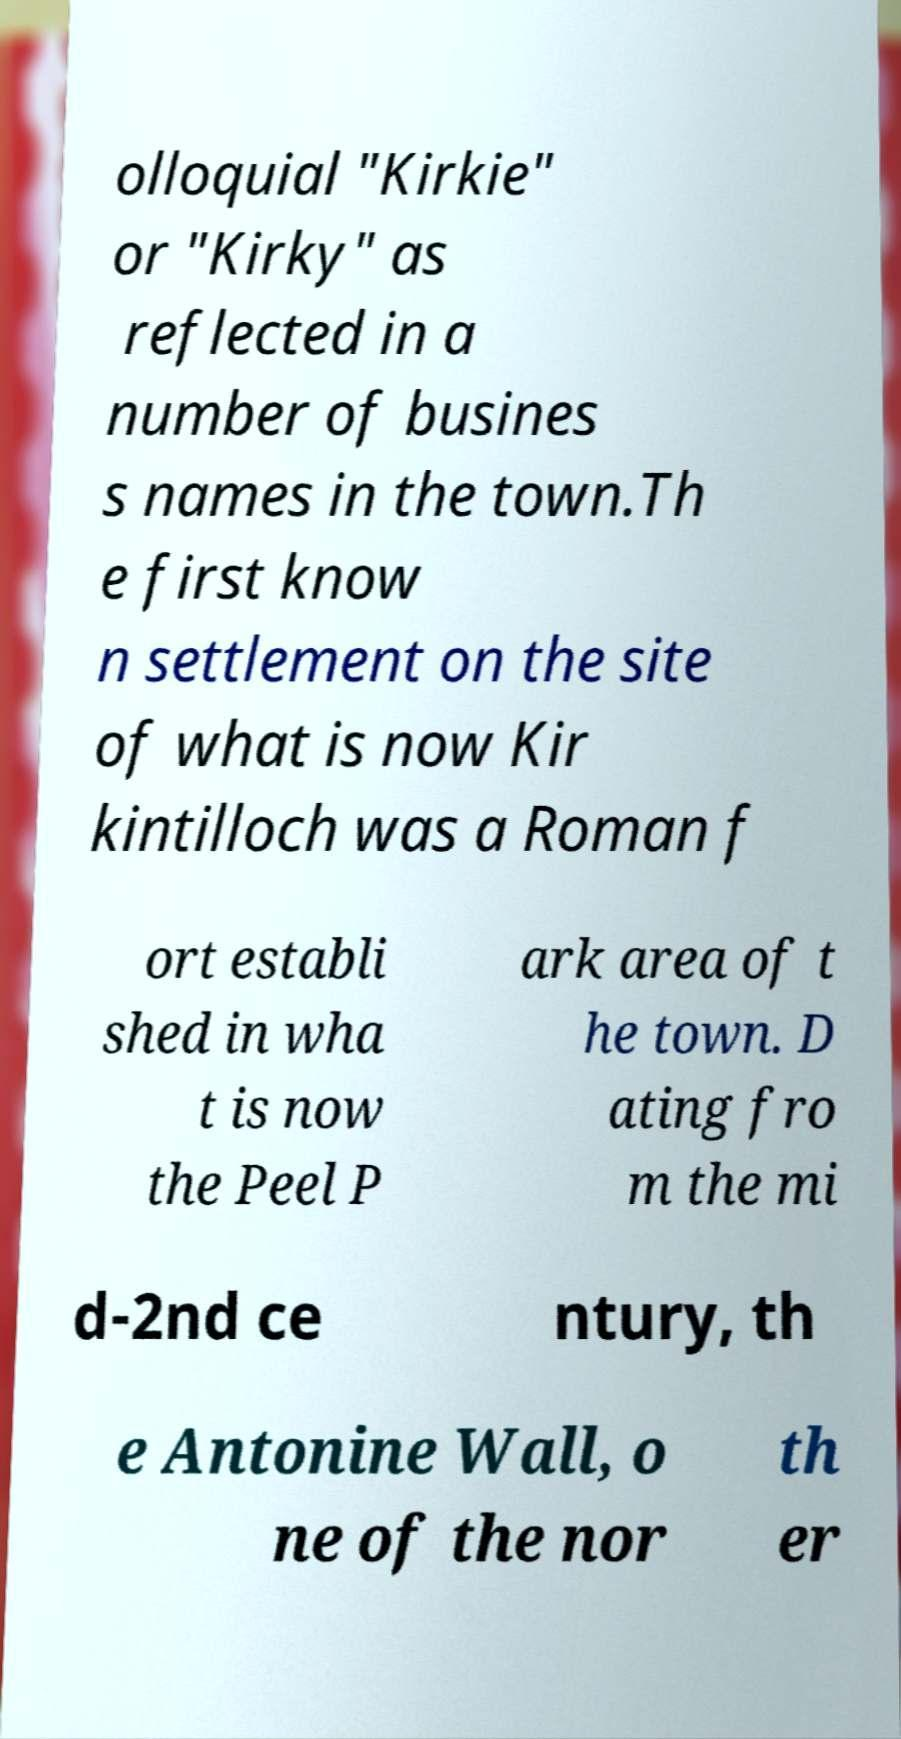Please read and relay the text visible in this image. What does it say? olloquial "Kirkie" or "Kirky" as reflected in a number of busines s names in the town.Th e first know n settlement on the site of what is now Kir kintilloch was a Roman f ort establi shed in wha t is now the Peel P ark area of t he town. D ating fro m the mi d-2nd ce ntury, th e Antonine Wall, o ne of the nor th er 